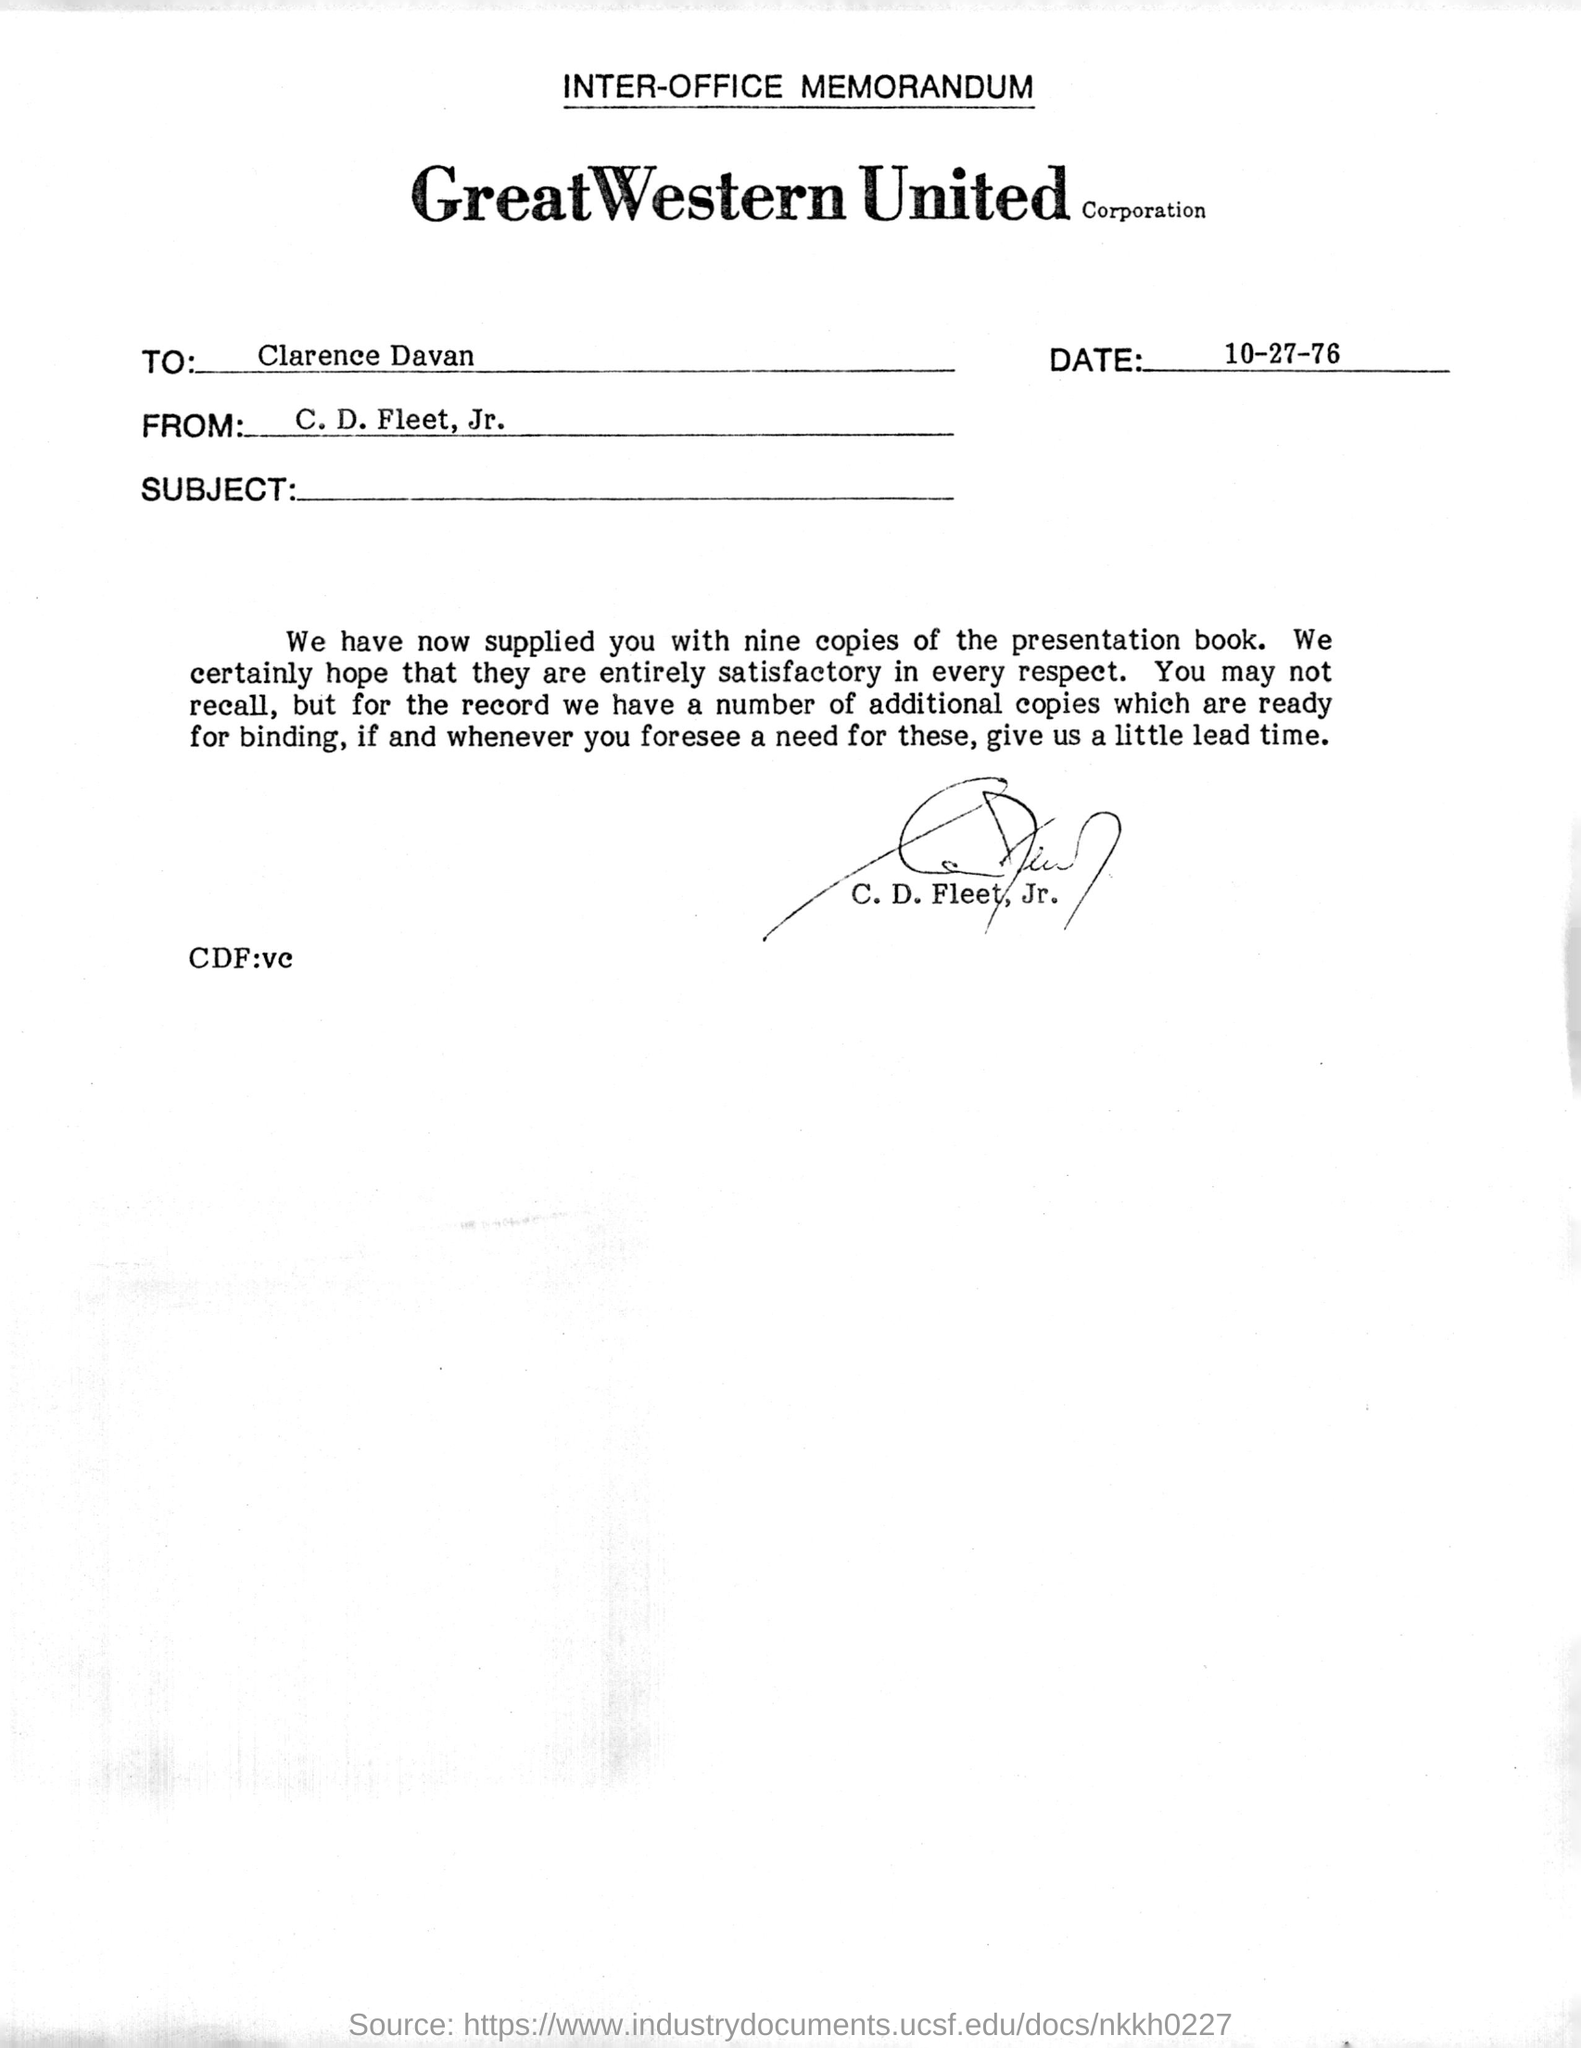What kind of memorandum is this ?
Keep it short and to the point. INTER-OFFICE MEMORANDUM. Who is the sender of this memorandum?
Provide a short and direct response. C. D. Fleet, Jr. Who is the receiver of the memorandum ?
Keep it short and to the point. Clarence Davan. When is the memorandum dated?
Ensure brevity in your answer.  10-27-76. Who has signed the memorandum?
Your answer should be very brief. C. D. Fleet, Jr. 